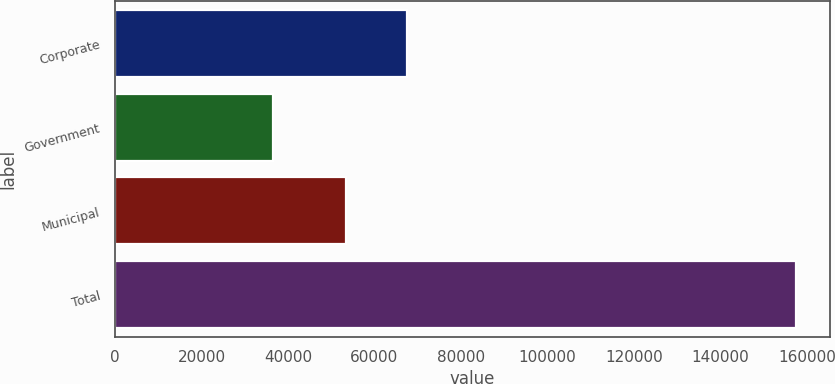Convert chart to OTSL. <chart><loc_0><loc_0><loc_500><loc_500><bar_chart><fcel>Corporate<fcel>Government<fcel>Municipal<fcel>Total<nl><fcel>67549<fcel>36472<fcel>53343<fcel>157364<nl></chart> 